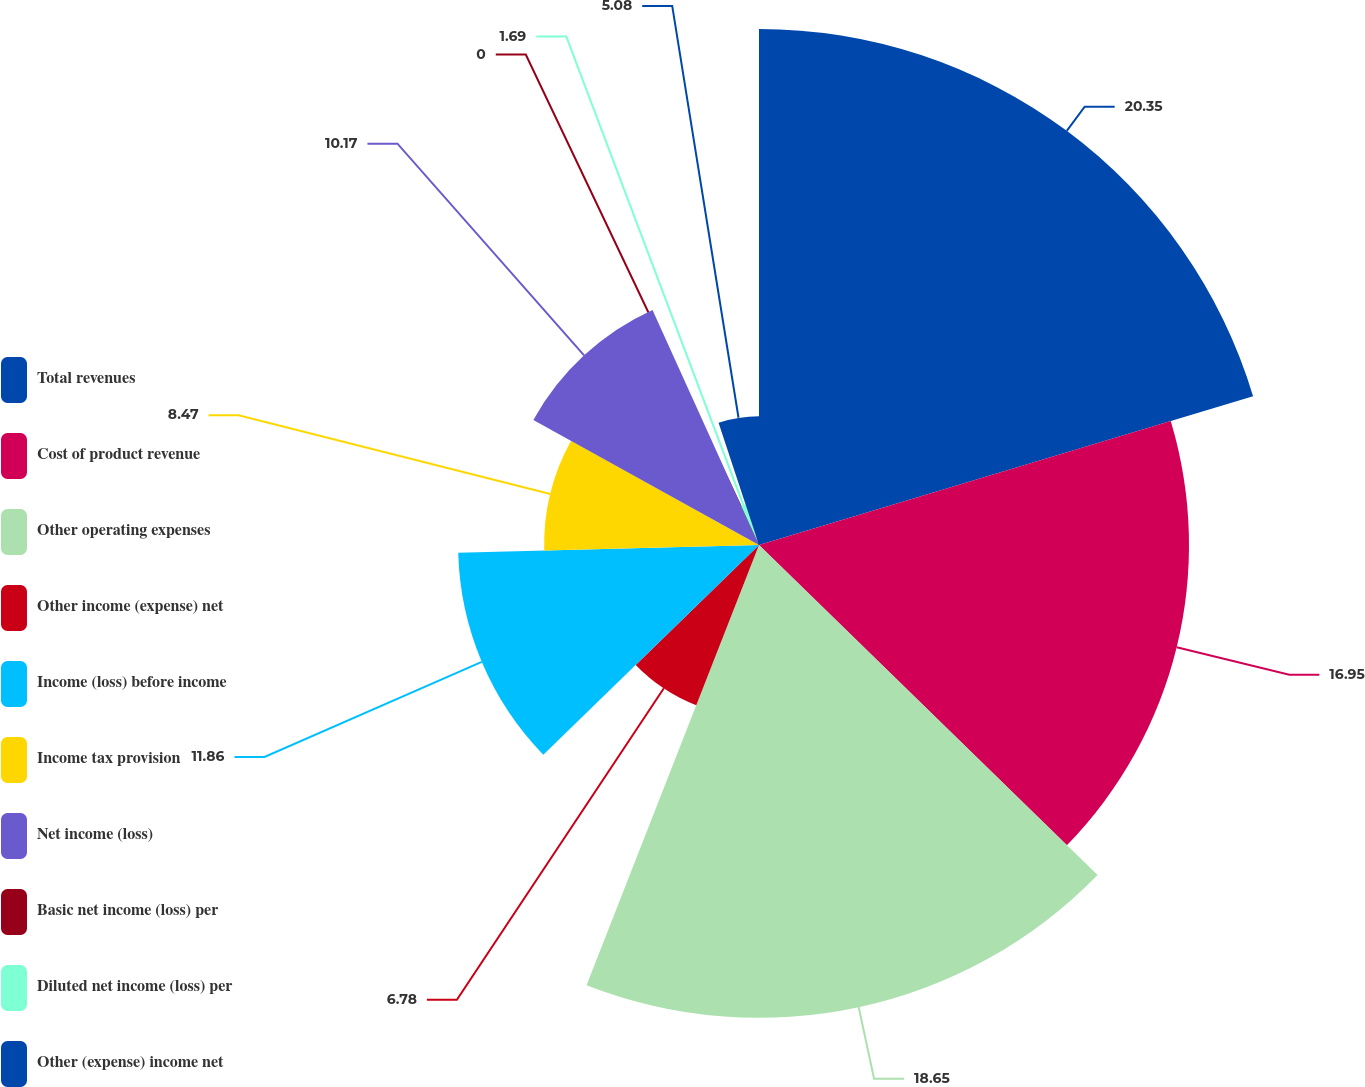Convert chart. <chart><loc_0><loc_0><loc_500><loc_500><pie_chart><fcel>Total revenues<fcel>Cost of product revenue<fcel>Other operating expenses<fcel>Other income (expense) net<fcel>Income (loss) before income<fcel>Income tax provision<fcel>Net income (loss)<fcel>Basic net income (loss) per<fcel>Diluted net income (loss) per<fcel>Other (expense) income net<nl><fcel>20.34%<fcel>16.95%<fcel>18.64%<fcel>6.78%<fcel>11.86%<fcel>8.47%<fcel>10.17%<fcel>0.0%<fcel>1.69%<fcel>5.08%<nl></chart> 